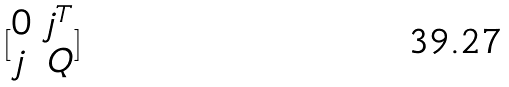Convert formula to latex. <formula><loc_0><loc_0><loc_500><loc_500>[ \begin{matrix} 0 & j ^ { T } \\ j & Q \end{matrix} ]</formula> 